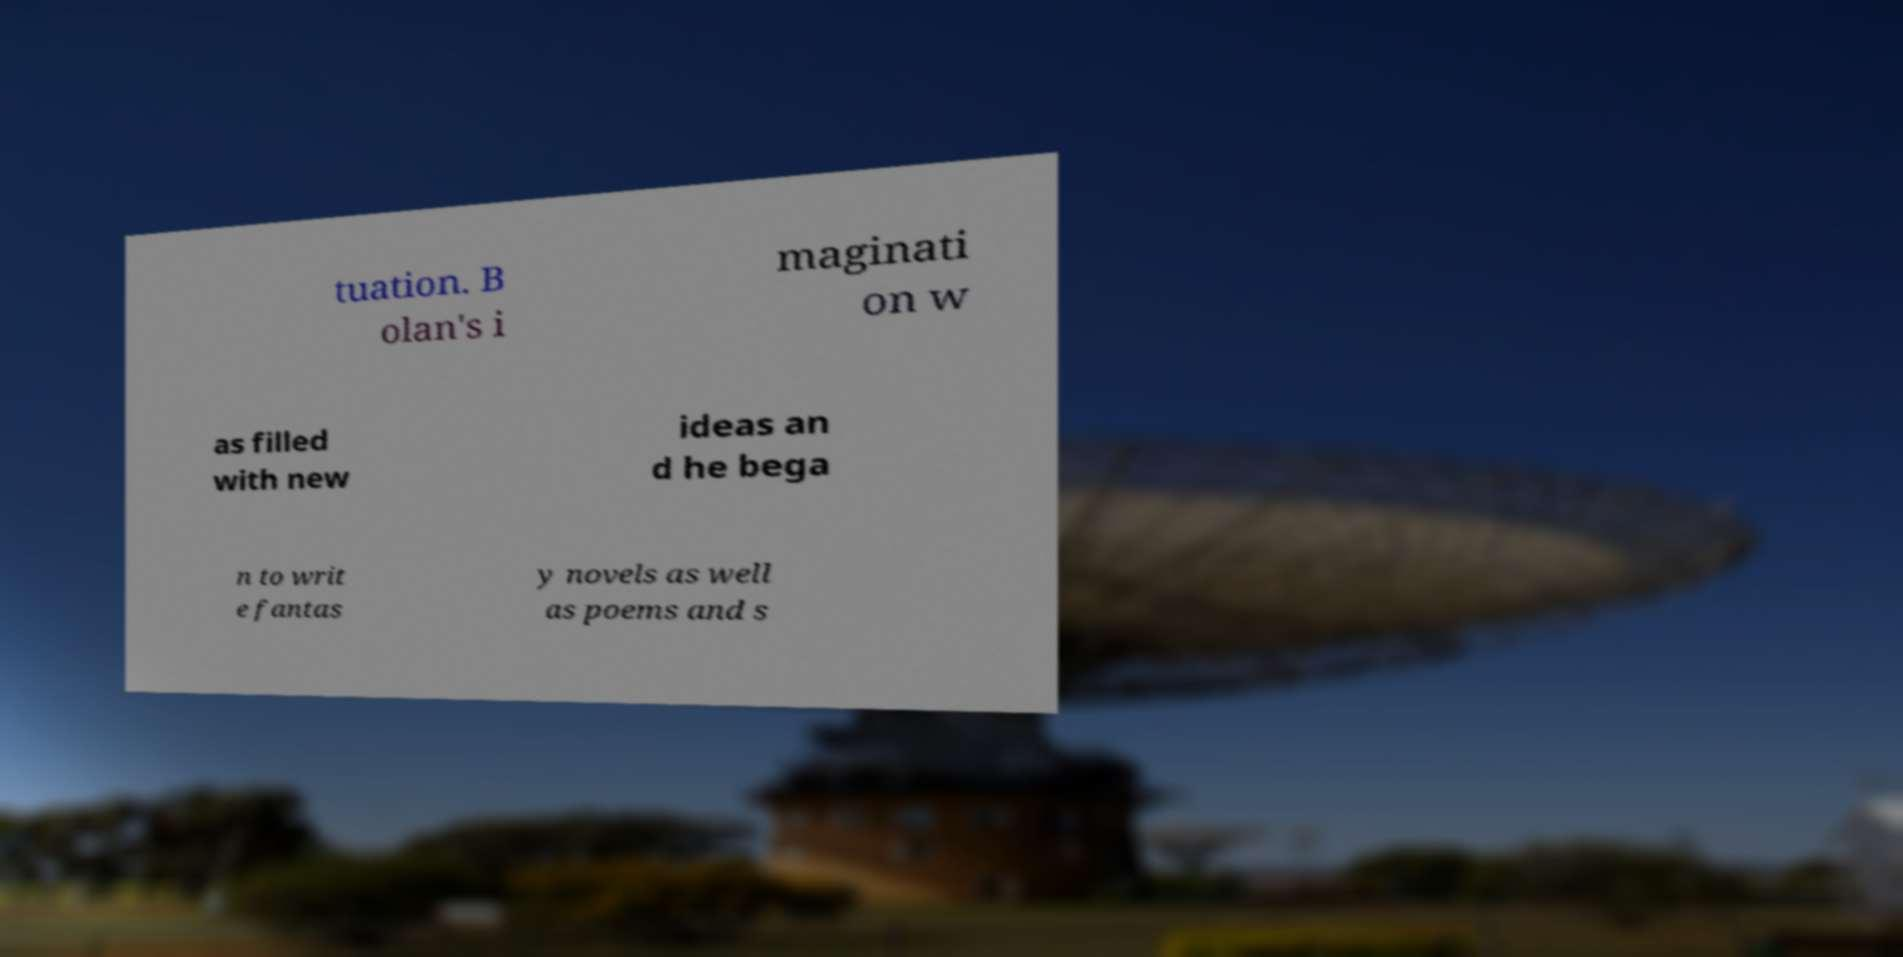Can you read and provide the text displayed in the image?This photo seems to have some interesting text. Can you extract and type it out for me? tuation. B olan's i maginati on w as filled with new ideas an d he bega n to writ e fantas y novels as well as poems and s 